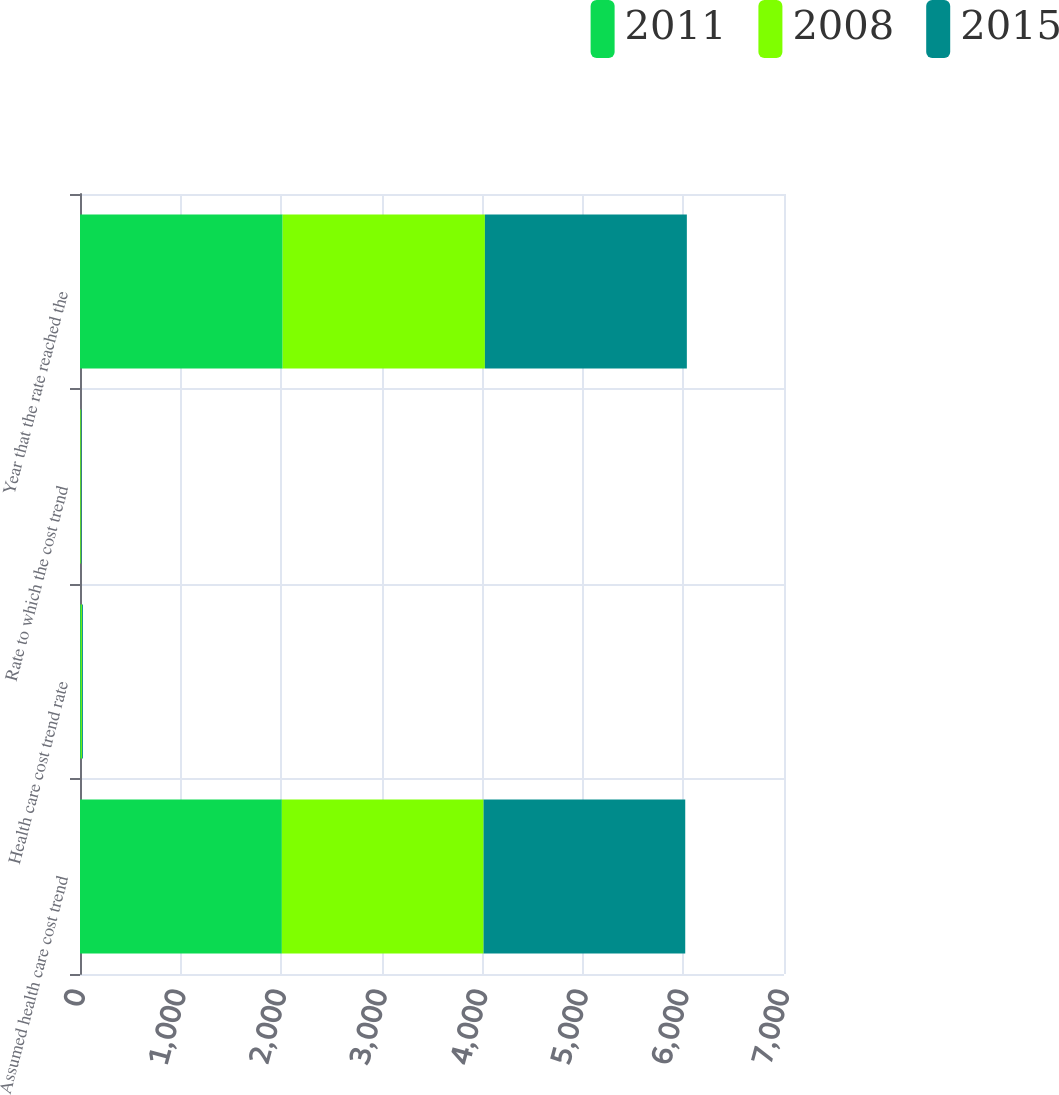Convert chart to OTSL. <chart><loc_0><loc_0><loc_500><loc_500><stacked_bar_chart><ecel><fcel>Assumed health care cost trend<fcel>Health care cost trend rate<fcel>Rate to which the cost trend<fcel>Year that the rate reached the<nl><fcel>2011<fcel>2007<fcel>9<fcel>5<fcel>2015<nl><fcel>2008<fcel>2006<fcel>10<fcel>5<fcel>2011<nl><fcel>2015<fcel>2005<fcel>10<fcel>5<fcel>2008<nl></chart> 